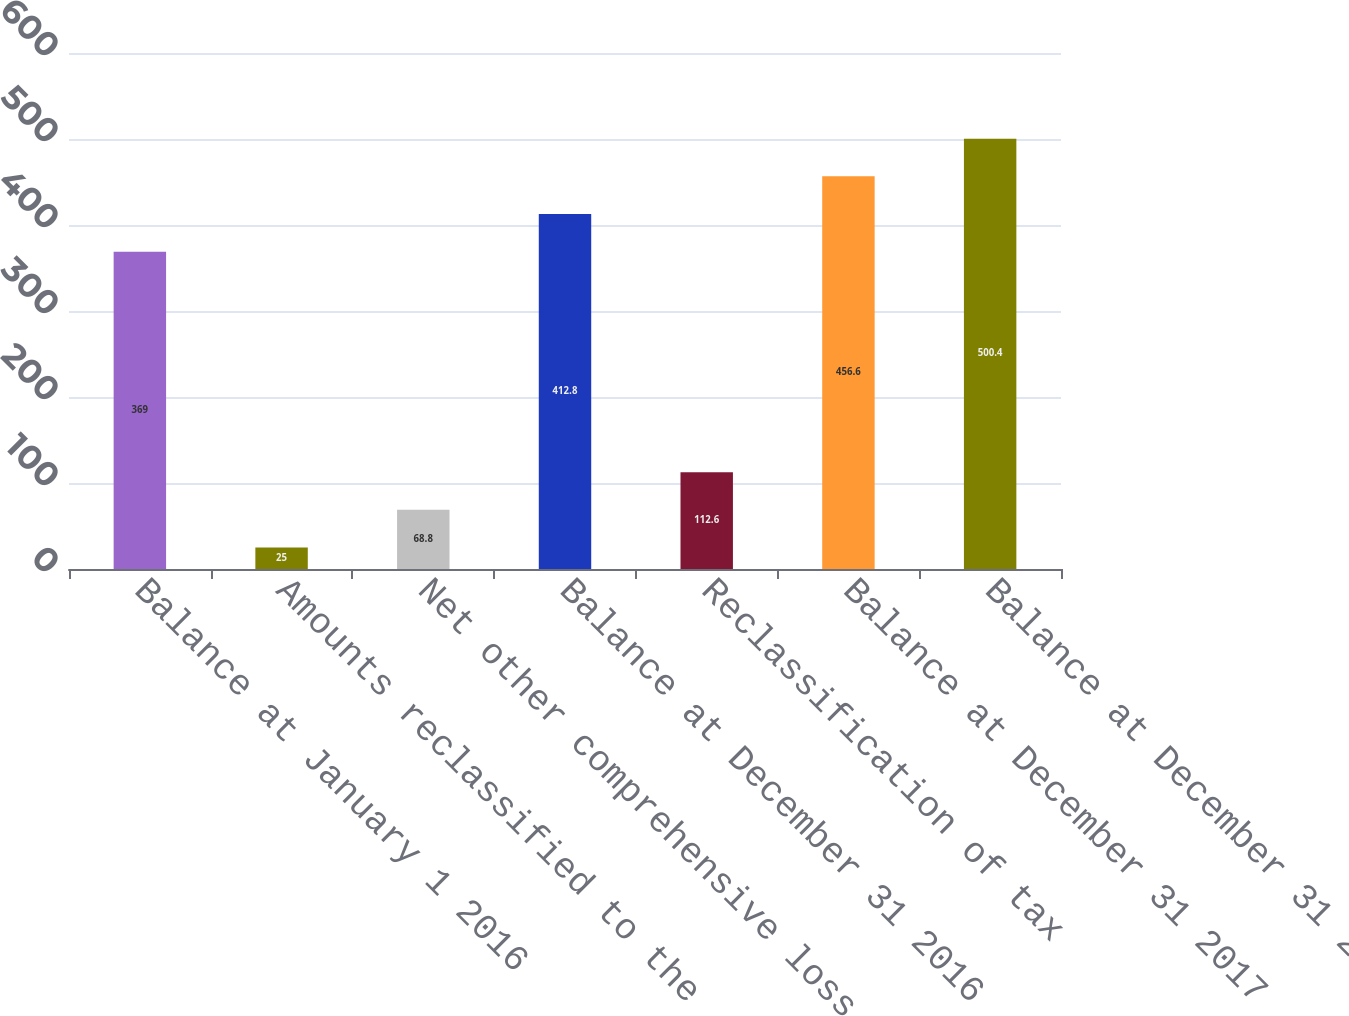Convert chart. <chart><loc_0><loc_0><loc_500><loc_500><bar_chart><fcel>Balance at January 1 2016<fcel>Amounts reclassified to the<fcel>Net other comprehensive loss<fcel>Balance at December 31 2016<fcel>Reclassification of tax<fcel>Balance at December 31 2017<fcel>Balance at December 31 2018<nl><fcel>369<fcel>25<fcel>68.8<fcel>412.8<fcel>112.6<fcel>456.6<fcel>500.4<nl></chart> 